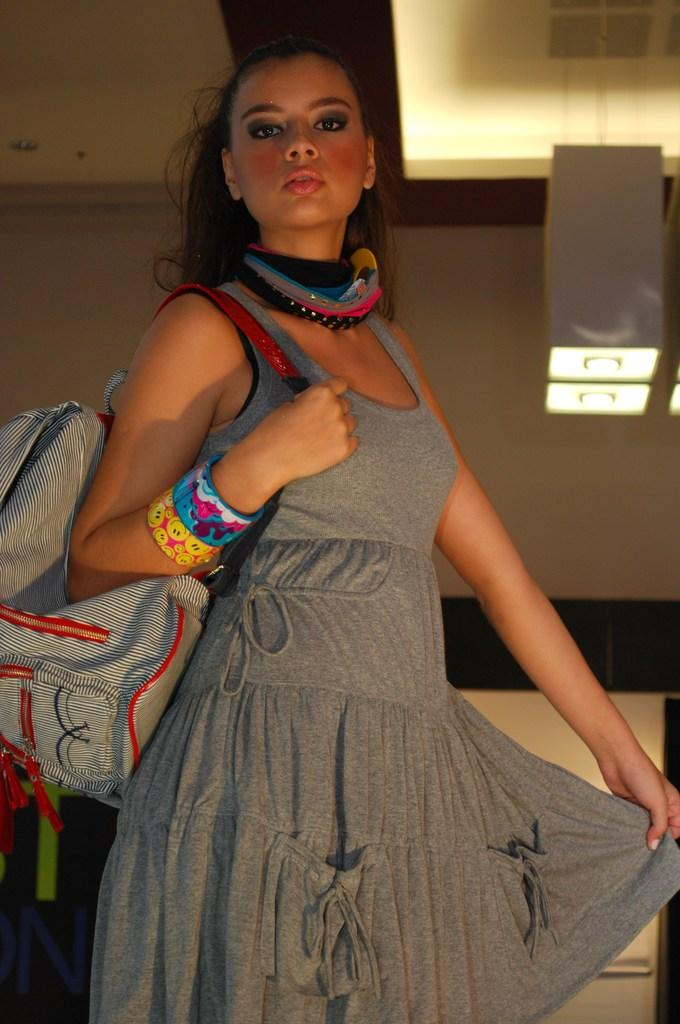What is the main subject of the image? There is a person in the image. What is the person wearing? The person is wearing a grey dress. Are there any accessories visible on the person? Yes, the person is wearing bangles. What is the person holding or carrying in the image? The person is carrying a bag. What can be seen in the background of the image? There are lights visible in the background of the image. What type of cream is being applied to the person's hand in the image? There is no cream being applied to the person's hand in the image. 